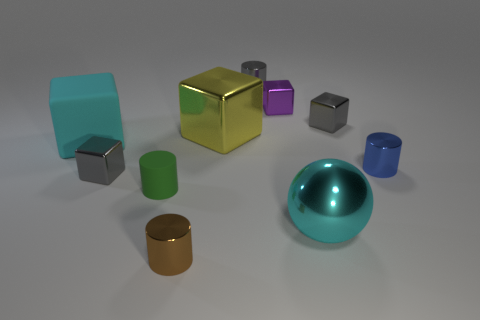Is the color of the metal ball the same as the big rubber block?
Make the answer very short. Yes. There is a matte cube that is the same color as the ball; what size is it?
Offer a terse response. Large. There is a thing that is the same color as the matte block; what is it made of?
Make the answer very short. Metal. What number of rubber objects are the same color as the big shiny sphere?
Offer a very short reply. 1. Is there anything else that has the same shape as the tiny green matte object?
Your answer should be very brief. Yes. There is a large metallic object in front of the blue object; what shape is it?
Provide a short and direct response. Sphere. There is a large cyan thing to the right of the gray metallic block in front of the large cube that is behind the large rubber block; what is its shape?
Offer a very short reply. Sphere. What number of things are gray matte spheres or big balls?
Provide a succinct answer. 1. Does the tiny gray thing left of the green matte thing have the same shape as the cyan object behind the cyan metal sphere?
Offer a very short reply. Yes. How many big metal things are both to the left of the cyan metal thing and in front of the tiny green object?
Give a very brief answer. 0. 